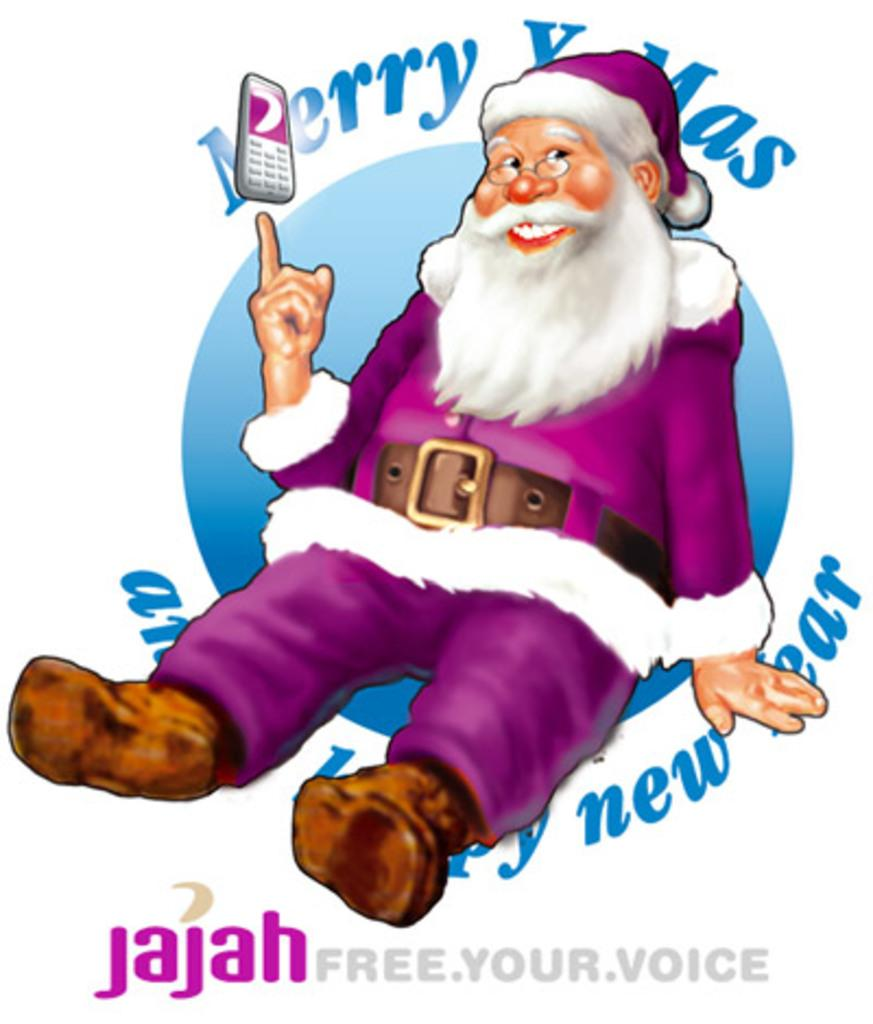What is the main subject of the image? There is a cartoon picture of Santa in the image. Where can text be found in the image? Text can be found at the top and bottom of the image. What type of marble is used to decorate the memory in the image? There is no marble or memory present in the image; it features a cartoon picture of Santa and text. 